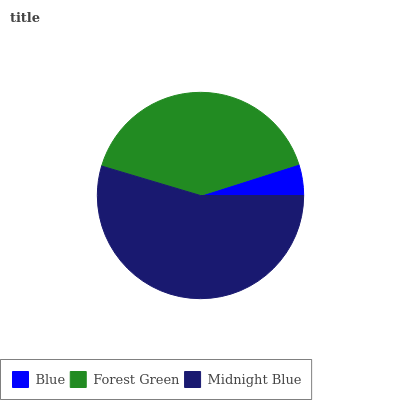Is Blue the minimum?
Answer yes or no. Yes. Is Midnight Blue the maximum?
Answer yes or no. Yes. Is Forest Green the minimum?
Answer yes or no. No. Is Forest Green the maximum?
Answer yes or no. No. Is Forest Green greater than Blue?
Answer yes or no. Yes. Is Blue less than Forest Green?
Answer yes or no. Yes. Is Blue greater than Forest Green?
Answer yes or no. No. Is Forest Green less than Blue?
Answer yes or no. No. Is Forest Green the high median?
Answer yes or no. Yes. Is Forest Green the low median?
Answer yes or no. Yes. Is Midnight Blue the high median?
Answer yes or no. No. Is Midnight Blue the low median?
Answer yes or no. No. 